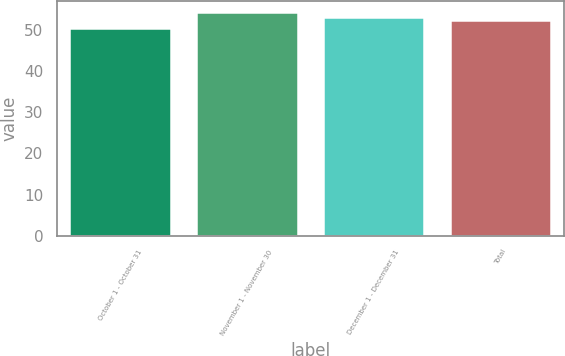Convert chart. <chart><loc_0><loc_0><loc_500><loc_500><bar_chart><fcel>October 1 - October 31<fcel>November 1 - November 30<fcel>December 1 - December 31<fcel>Total<nl><fcel>50.45<fcel>54.25<fcel>53.06<fcel>52.35<nl></chart> 